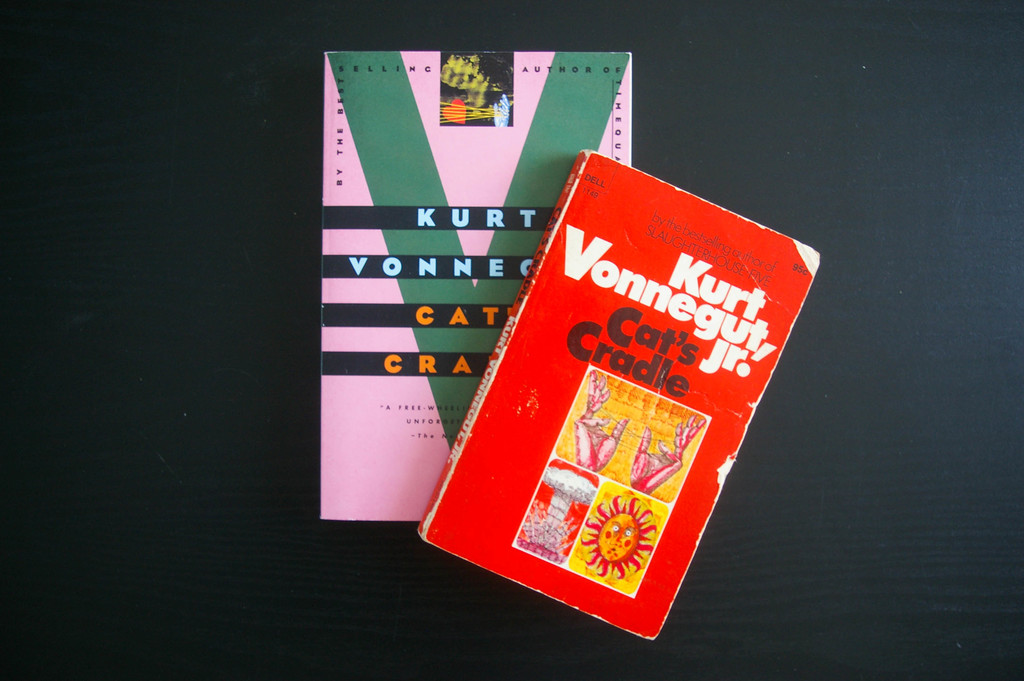What themes are explored in 'Cat's Cradle' by Kurt Vonnegut, and how might they relate to the visual presentation of the book in this image? 'Cat's Cradle' delves into themes of science, religion, and ethical ambiguity. The battered and vivid cover visually symbolizes the chaotic and unpredictable story within, contrasting the orderly and calm black backdrop which might suggest a stark, void universe Vonnegut often portrays. 